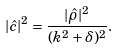Convert formula to latex. <formula><loc_0><loc_0><loc_500><loc_500>| \hat { c } | ^ { 2 } = \frac { | \hat { \rho } | ^ { 2 } } { ( k ^ { 2 } + \delta ) ^ { 2 } } .</formula> 